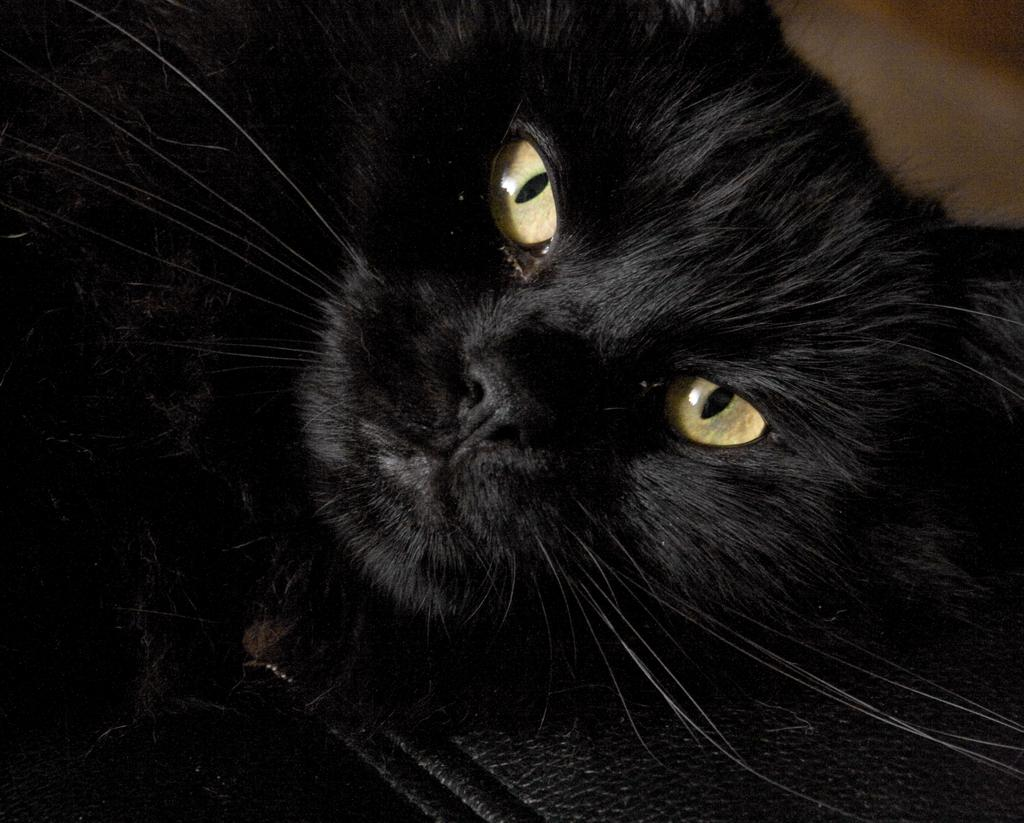What type of animal is in the image? There is a black cat in the image. Can you describe the object at the bottom of the image? Unfortunately, there is not enough information provided to describe the object at the bottom of the image. What type of zephyr can be seen in the image? There is no zephyr present in the image. Is there a hospital visible in the image? There is no information provided about a hospital in the image. 